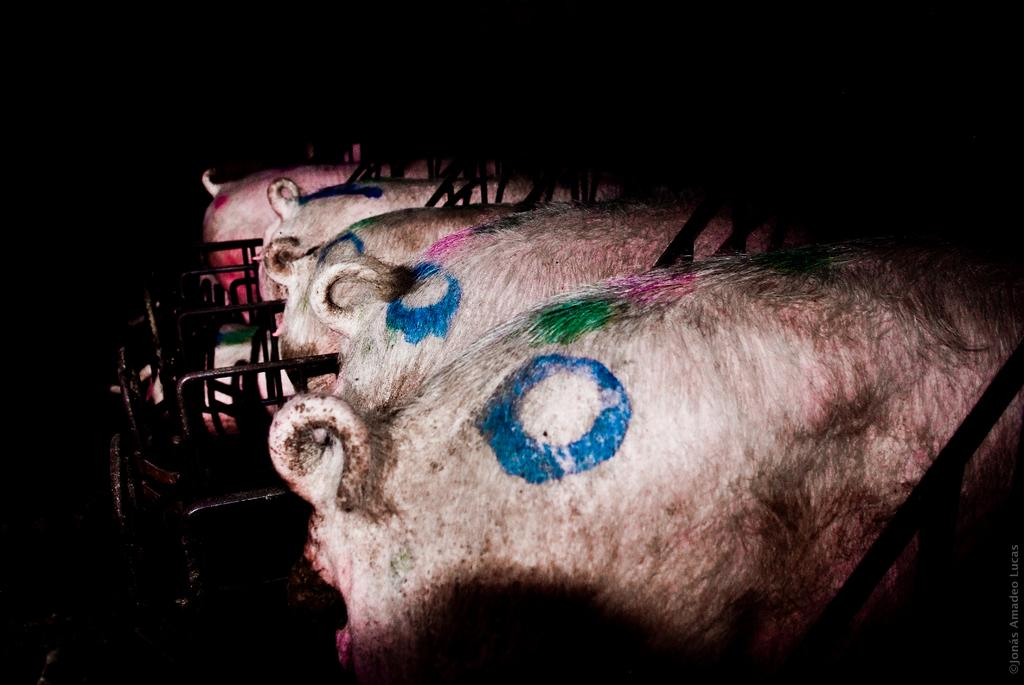How many animals are present in the image? There are four pigs in the image. What direction are the pigs facing? The pigs are facing away from the viewer. What colors can be seen on top of the pigs? There are blue, green, and pink colors on top of the pigs. Can you describe the background of the image? The background of the image is dark. What type of cheese is being offered to the pigs by their parent in the image? There is no cheese or parent present in the image; it features four pigs with colors on top of them against a dark background. 